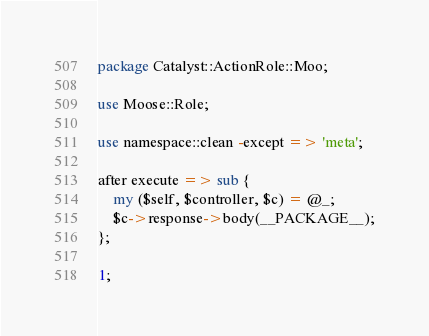Convert code to text. <code><loc_0><loc_0><loc_500><loc_500><_Perl_>package Catalyst::ActionRole::Moo;

use Moose::Role;

use namespace::clean -except => 'meta';

after execute => sub {
    my ($self, $controller, $c) = @_;
    $c->response->body(__PACKAGE__);
};

1;
</code> 